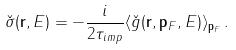Convert formula to latex. <formula><loc_0><loc_0><loc_500><loc_500>\check { \sigma } ( { \mathbf r } , E ) = - \frac { i } { 2 \tau _ { i m p } } \langle \check { g } ( { \mathbf r } , { \mathbf p _ { F } } , E ) \rangle _ { \mathbf p _ { F } } \, .</formula> 